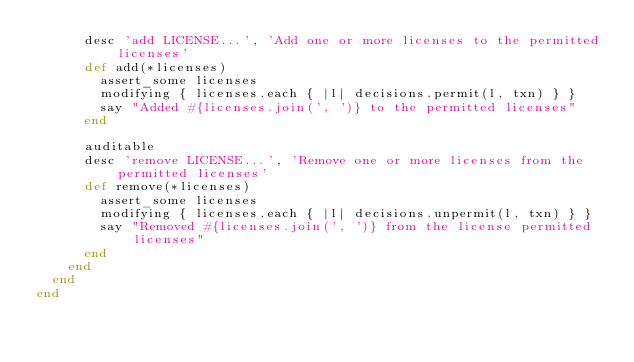<code> <loc_0><loc_0><loc_500><loc_500><_Ruby_>      desc 'add LICENSE...', 'Add one or more licenses to the permitted licenses'
      def add(*licenses)
        assert_some licenses
        modifying { licenses.each { |l| decisions.permit(l, txn) } }
        say "Added #{licenses.join(', ')} to the permitted licenses"
      end

      auditable
      desc 'remove LICENSE...', 'Remove one or more licenses from the permitted licenses'
      def remove(*licenses)
        assert_some licenses
        modifying { licenses.each { |l| decisions.unpermit(l, txn) } }
        say "Removed #{licenses.join(', ')} from the license permitted licenses"
      end
    end
  end
end
</code> 